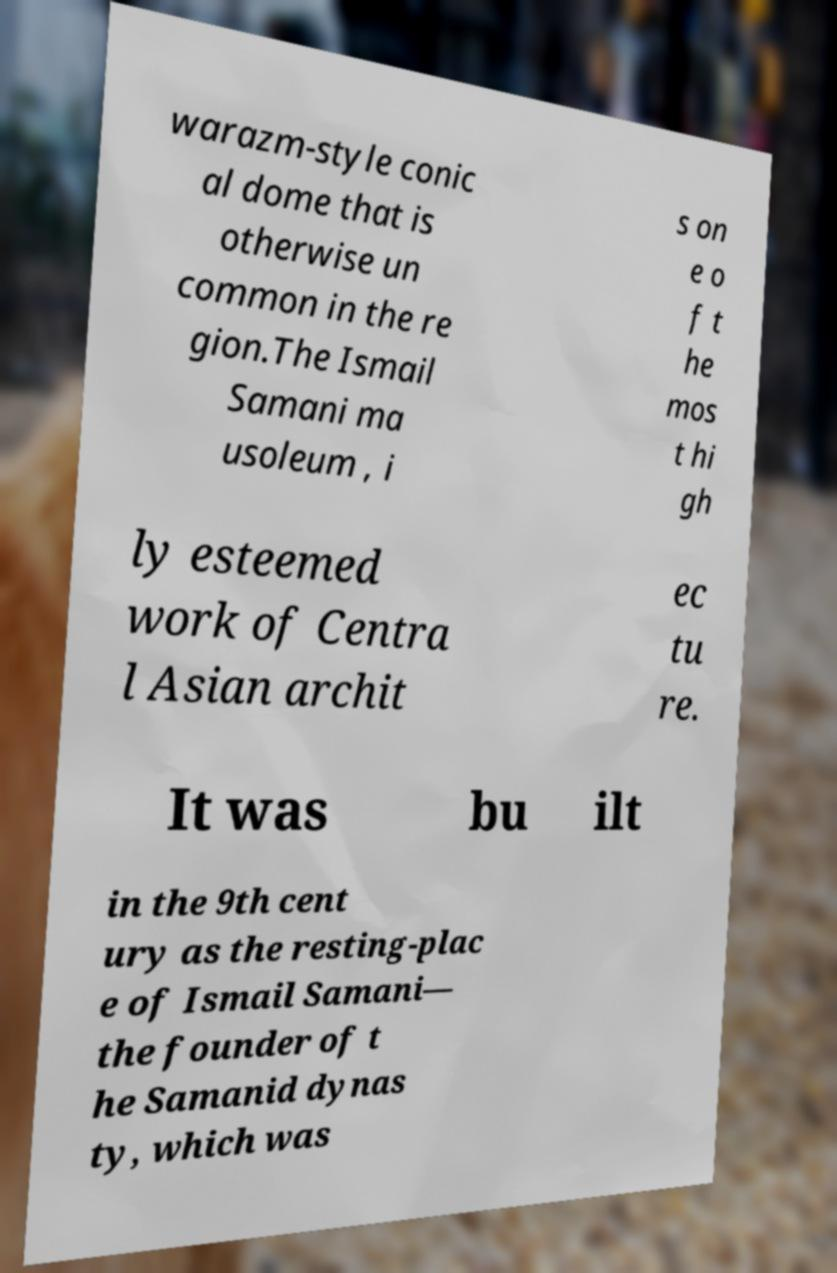Please read and relay the text visible in this image. What does it say? warazm-style conic al dome that is otherwise un common in the re gion.The Ismail Samani ma usoleum , i s on e o f t he mos t hi gh ly esteemed work of Centra l Asian archit ec tu re. It was bu ilt in the 9th cent ury as the resting-plac e of Ismail Samani— the founder of t he Samanid dynas ty, which was 